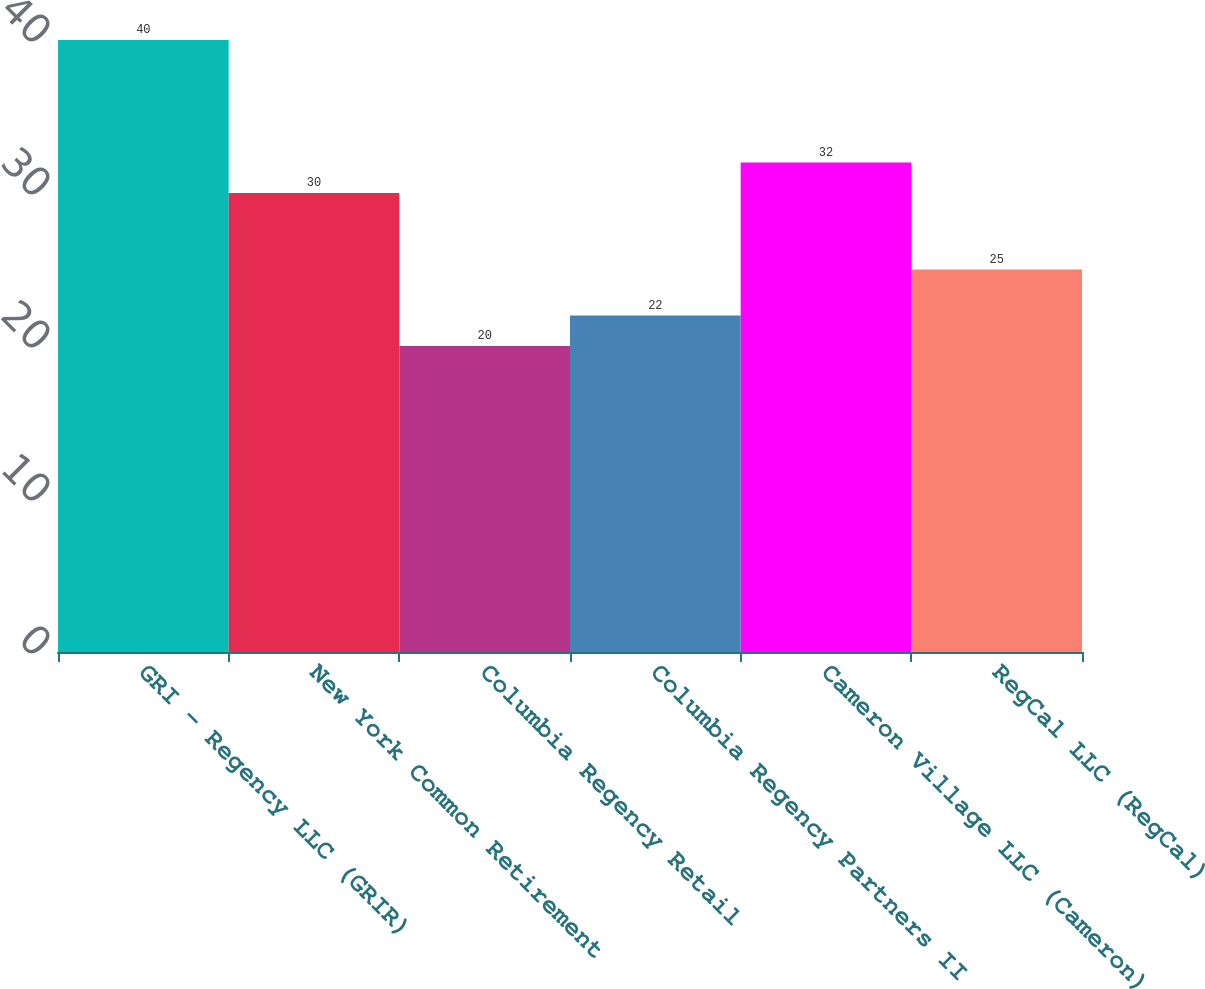Convert chart to OTSL. <chart><loc_0><loc_0><loc_500><loc_500><bar_chart><fcel>GRI - Regency LLC (GRIR)<fcel>New York Common Retirement<fcel>Columbia Regency Retail<fcel>Columbia Regency Partners II<fcel>Cameron Village LLC (Cameron)<fcel>RegCal LLC (RegCal)<nl><fcel>40<fcel>30<fcel>20<fcel>22<fcel>32<fcel>25<nl></chart> 